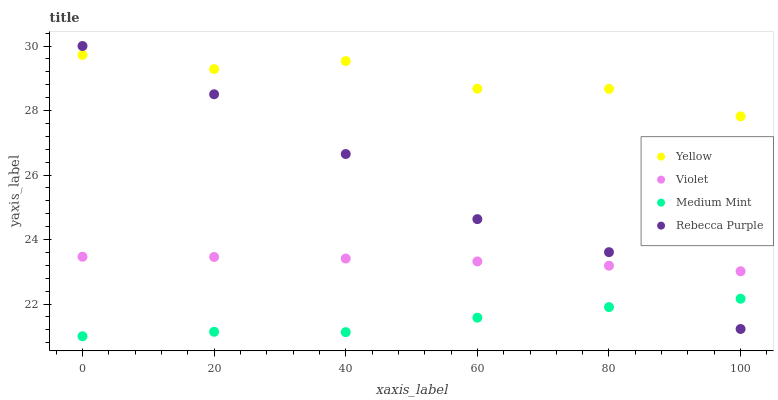Does Medium Mint have the minimum area under the curve?
Answer yes or no. Yes. Does Yellow have the maximum area under the curve?
Answer yes or no. Yes. Does Rebecca Purple have the minimum area under the curve?
Answer yes or no. No. Does Rebecca Purple have the maximum area under the curve?
Answer yes or no. No. Is Violet the smoothest?
Answer yes or no. Yes. Is Yellow the roughest?
Answer yes or no. Yes. Is Rebecca Purple the smoothest?
Answer yes or no. No. Is Rebecca Purple the roughest?
Answer yes or no. No. Does Medium Mint have the lowest value?
Answer yes or no. Yes. Does Rebecca Purple have the lowest value?
Answer yes or no. No. Does Rebecca Purple have the highest value?
Answer yes or no. Yes. Does Yellow have the highest value?
Answer yes or no. No. Is Medium Mint less than Yellow?
Answer yes or no. Yes. Is Yellow greater than Violet?
Answer yes or no. Yes. Does Rebecca Purple intersect Medium Mint?
Answer yes or no. Yes. Is Rebecca Purple less than Medium Mint?
Answer yes or no. No. Is Rebecca Purple greater than Medium Mint?
Answer yes or no. No. Does Medium Mint intersect Yellow?
Answer yes or no. No. 